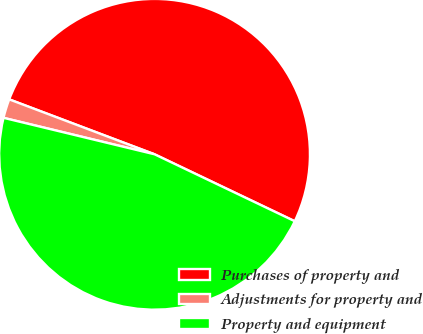Convert chart. <chart><loc_0><loc_0><loc_500><loc_500><pie_chart><fcel>Purchases of property and<fcel>Adjustments for property and<fcel>Property and equipment<nl><fcel>51.34%<fcel>1.98%<fcel>46.68%<nl></chart> 